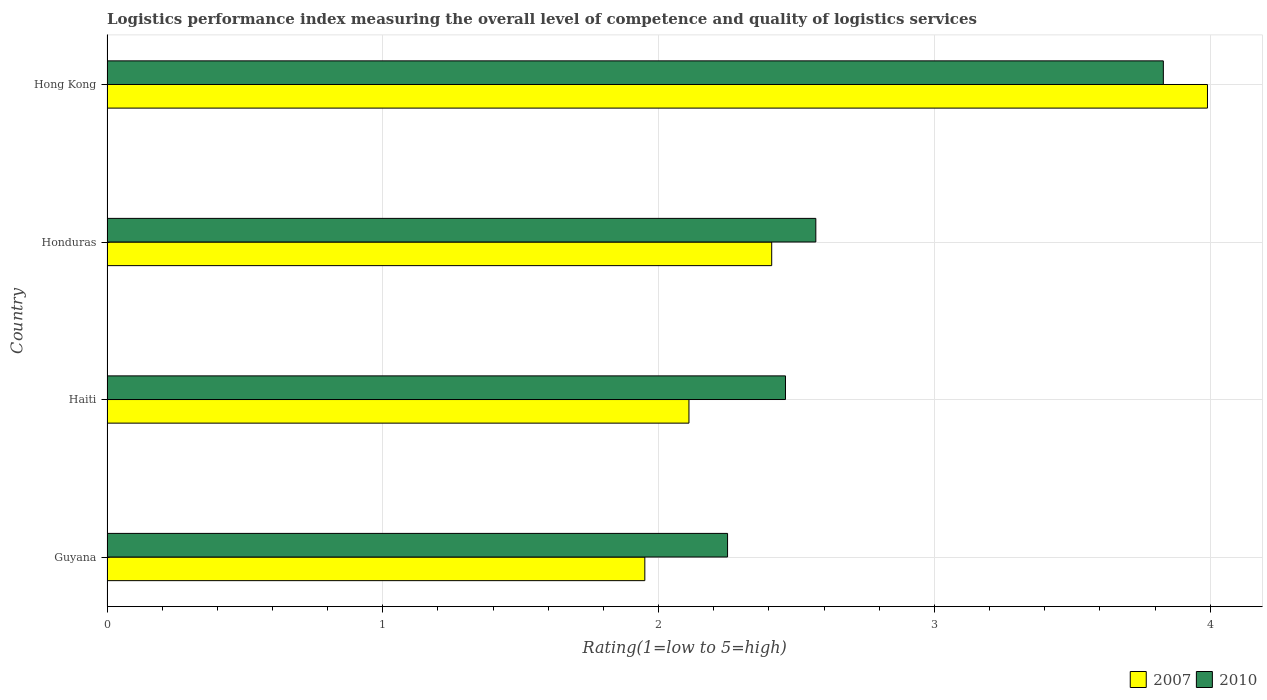How many bars are there on the 4th tick from the top?
Ensure brevity in your answer.  2. What is the label of the 4th group of bars from the top?
Your answer should be very brief. Guyana. In how many cases, is the number of bars for a given country not equal to the number of legend labels?
Provide a succinct answer. 0. What is the Logistic performance index in 2007 in Honduras?
Your answer should be very brief. 2.41. Across all countries, what is the maximum Logistic performance index in 2007?
Your answer should be very brief. 3.99. Across all countries, what is the minimum Logistic performance index in 2007?
Give a very brief answer. 1.95. In which country was the Logistic performance index in 2010 maximum?
Your answer should be very brief. Hong Kong. In which country was the Logistic performance index in 2007 minimum?
Ensure brevity in your answer.  Guyana. What is the total Logistic performance index in 2007 in the graph?
Provide a succinct answer. 10.46. What is the difference between the Logistic performance index in 2007 in Guyana and that in Hong Kong?
Your answer should be very brief. -2.04. What is the difference between the Logistic performance index in 2007 in Guyana and the Logistic performance index in 2010 in Honduras?
Your answer should be compact. -0.62. What is the average Logistic performance index in 2010 per country?
Your answer should be very brief. 2.78. What is the difference between the Logistic performance index in 2010 and Logistic performance index in 2007 in Haiti?
Offer a terse response. 0.35. What is the ratio of the Logistic performance index in 2007 in Guyana to that in Haiti?
Your response must be concise. 0.92. What is the difference between the highest and the second highest Logistic performance index in 2010?
Provide a short and direct response. 1.26. What is the difference between the highest and the lowest Logistic performance index in 2010?
Provide a succinct answer. 1.58. What does the 2nd bar from the top in Guyana represents?
Offer a terse response. 2007. How many bars are there?
Offer a very short reply. 8. Are all the bars in the graph horizontal?
Your answer should be very brief. Yes. Are the values on the major ticks of X-axis written in scientific E-notation?
Your answer should be very brief. No. How are the legend labels stacked?
Keep it short and to the point. Horizontal. What is the title of the graph?
Your answer should be compact. Logistics performance index measuring the overall level of competence and quality of logistics services. What is the label or title of the X-axis?
Make the answer very short. Rating(1=low to 5=high). What is the label or title of the Y-axis?
Provide a short and direct response. Country. What is the Rating(1=low to 5=high) in 2007 in Guyana?
Your answer should be compact. 1.95. What is the Rating(1=low to 5=high) in 2010 in Guyana?
Offer a terse response. 2.25. What is the Rating(1=low to 5=high) in 2007 in Haiti?
Your response must be concise. 2.11. What is the Rating(1=low to 5=high) of 2010 in Haiti?
Offer a terse response. 2.46. What is the Rating(1=low to 5=high) in 2007 in Honduras?
Ensure brevity in your answer.  2.41. What is the Rating(1=low to 5=high) in 2010 in Honduras?
Your answer should be compact. 2.57. What is the Rating(1=low to 5=high) in 2007 in Hong Kong?
Your answer should be very brief. 3.99. What is the Rating(1=low to 5=high) of 2010 in Hong Kong?
Keep it short and to the point. 3.83. Across all countries, what is the maximum Rating(1=low to 5=high) in 2007?
Keep it short and to the point. 3.99. Across all countries, what is the maximum Rating(1=low to 5=high) of 2010?
Your response must be concise. 3.83. Across all countries, what is the minimum Rating(1=low to 5=high) in 2007?
Your answer should be compact. 1.95. Across all countries, what is the minimum Rating(1=low to 5=high) in 2010?
Your response must be concise. 2.25. What is the total Rating(1=low to 5=high) of 2007 in the graph?
Provide a short and direct response. 10.46. What is the total Rating(1=low to 5=high) of 2010 in the graph?
Give a very brief answer. 11.11. What is the difference between the Rating(1=low to 5=high) in 2007 in Guyana and that in Haiti?
Give a very brief answer. -0.16. What is the difference between the Rating(1=low to 5=high) in 2010 in Guyana and that in Haiti?
Offer a very short reply. -0.21. What is the difference between the Rating(1=low to 5=high) in 2007 in Guyana and that in Honduras?
Ensure brevity in your answer.  -0.46. What is the difference between the Rating(1=low to 5=high) in 2010 in Guyana and that in Honduras?
Provide a short and direct response. -0.32. What is the difference between the Rating(1=low to 5=high) in 2007 in Guyana and that in Hong Kong?
Your answer should be very brief. -2.04. What is the difference between the Rating(1=low to 5=high) in 2010 in Guyana and that in Hong Kong?
Ensure brevity in your answer.  -1.58. What is the difference between the Rating(1=low to 5=high) of 2010 in Haiti and that in Honduras?
Provide a short and direct response. -0.11. What is the difference between the Rating(1=low to 5=high) of 2007 in Haiti and that in Hong Kong?
Your response must be concise. -1.88. What is the difference between the Rating(1=low to 5=high) in 2010 in Haiti and that in Hong Kong?
Give a very brief answer. -1.37. What is the difference between the Rating(1=low to 5=high) in 2007 in Honduras and that in Hong Kong?
Ensure brevity in your answer.  -1.58. What is the difference between the Rating(1=low to 5=high) of 2010 in Honduras and that in Hong Kong?
Your response must be concise. -1.26. What is the difference between the Rating(1=low to 5=high) of 2007 in Guyana and the Rating(1=low to 5=high) of 2010 in Haiti?
Keep it short and to the point. -0.51. What is the difference between the Rating(1=low to 5=high) in 2007 in Guyana and the Rating(1=low to 5=high) in 2010 in Honduras?
Keep it short and to the point. -0.62. What is the difference between the Rating(1=low to 5=high) of 2007 in Guyana and the Rating(1=low to 5=high) of 2010 in Hong Kong?
Ensure brevity in your answer.  -1.88. What is the difference between the Rating(1=low to 5=high) of 2007 in Haiti and the Rating(1=low to 5=high) of 2010 in Honduras?
Offer a very short reply. -0.46. What is the difference between the Rating(1=low to 5=high) of 2007 in Haiti and the Rating(1=low to 5=high) of 2010 in Hong Kong?
Your answer should be compact. -1.72. What is the difference between the Rating(1=low to 5=high) of 2007 in Honduras and the Rating(1=low to 5=high) of 2010 in Hong Kong?
Provide a short and direct response. -1.42. What is the average Rating(1=low to 5=high) of 2007 per country?
Keep it short and to the point. 2.62. What is the average Rating(1=low to 5=high) of 2010 per country?
Provide a short and direct response. 2.78. What is the difference between the Rating(1=low to 5=high) of 2007 and Rating(1=low to 5=high) of 2010 in Guyana?
Offer a terse response. -0.3. What is the difference between the Rating(1=low to 5=high) in 2007 and Rating(1=low to 5=high) in 2010 in Haiti?
Offer a terse response. -0.35. What is the difference between the Rating(1=low to 5=high) of 2007 and Rating(1=low to 5=high) of 2010 in Honduras?
Your response must be concise. -0.16. What is the difference between the Rating(1=low to 5=high) in 2007 and Rating(1=low to 5=high) in 2010 in Hong Kong?
Give a very brief answer. 0.16. What is the ratio of the Rating(1=low to 5=high) of 2007 in Guyana to that in Haiti?
Keep it short and to the point. 0.92. What is the ratio of the Rating(1=low to 5=high) in 2010 in Guyana to that in Haiti?
Your answer should be very brief. 0.91. What is the ratio of the Rating(1=low to 5=high) of 2007 in Guyana to that in Honduras?
Provide a succinct answer. 0.81. What is the ratio of the Rating(1=low to 5=high) of 2010 in Guyana to that in Honduras?
Offer a terse response. 0.88. What is the ratio of the Rating(1=low to 5=high) of 2007 in Guyana to that in Hong Kong?
Your answer should be very brief. 0.49. What is the ratio of the Rating(1=low to 5=high) of 2010 in Guyana to that in Hong Kong?
Offer a very short reply. 0.59. What is the ratio of the Rating(1=low to 5=high) of 2007 in Haiti to that in Honduras?
Offer a terse response. 0.88. What is the ratio of the Rating(1=low to 5=high) in 2010 in Haiti to that in Honduras?
Offer a terse response. 0.96. What is the ratio of the Rating(1=low to 5=high) in 2007 in Haiti to that in Hong Kong?
Your response must be concise. 0.53. What is the ratio of the Rating(1=low to 5=high) of 2010 in Haiti to that in Hong Kong?
Your response must be concise. 0.64. What is the ratio of the Rating(1=low to 5=high) of 2007 in Honduras to that in Hong Kong?
Keep it short and to the point. 0.6. What is the ratio of the Rating(1=low to 5=high) of 2010 in Honduras to that in Hong Kong?
Your answer should be very brief. 0.67. What is the difference between the highest and the second highest Rating(1=low to 5=high) in 2007?
Provide a succinct answer. 1.58. What is the difference between the highest and the second highest Rating(1=low to 5=high) of 2010?
Give a very brief answer. 1.26. What is the difference between the highest and the lowest Rating(1=low to 5=high) of 2007?
Provide a succinct answer. 2.04. What is the difference between the highest and the lowest Rating(1=low to 5=high) of 2010?
Give a very brief answer. 1.58. 